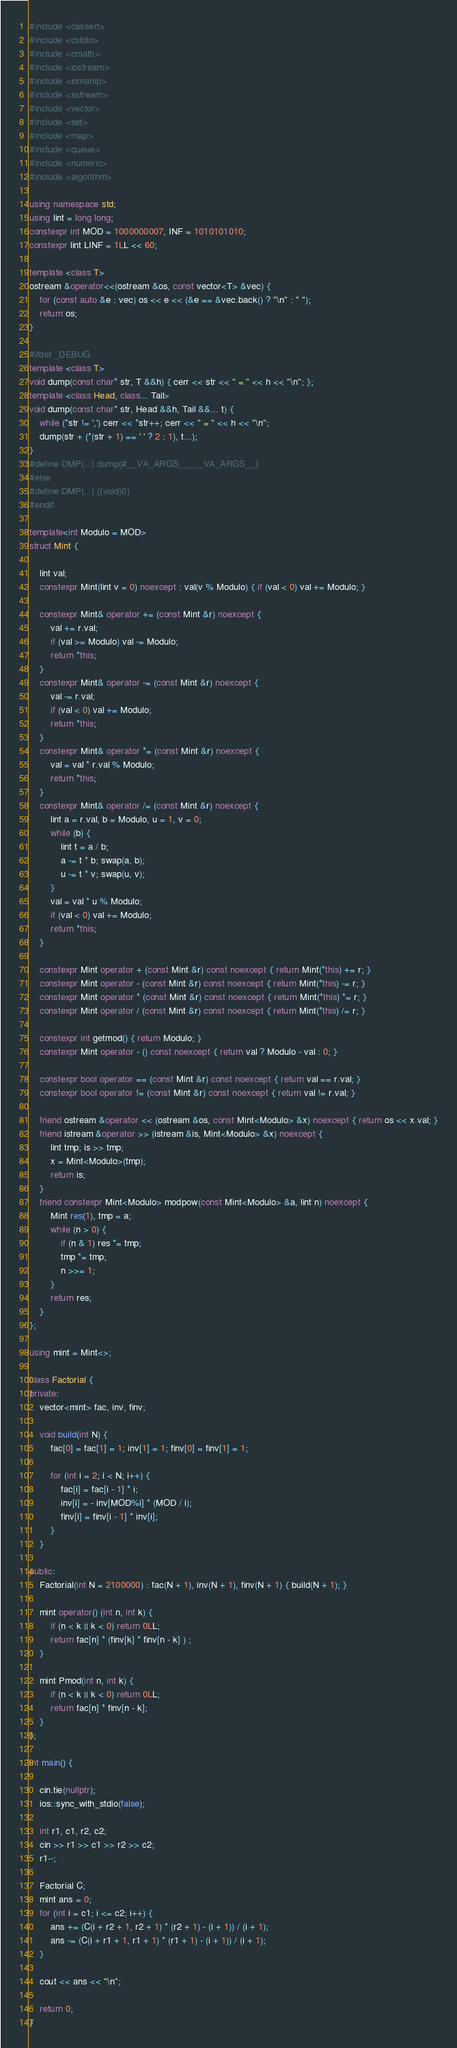Convert code to text. <code><loc_0><loc_0><loc_500><loc_500><_C++_>#include <cassert>
#include <cstdio>
#include <cmath>
#include <iostream>
#include <iomanip>
#include <sstream>
#include <vector>
#include <set>
#include <map>
#include <queue>
#include <numeric>
#include <algorithm>

using namespace std;
using lint = long long;
constexpr int MOD = 1000000007, INF = 1010101010;
constexpr lint LINF = 1LL << 60;

template <class T>
ostream &operator<<(ostream &os, const vector<T> &vec) {
	for (const auto &e : vec) os << e << (&e == &vec.back() ? "\n" : " ");
	return os;
}

#ifdef _DEBUG
template <class T>
void dump(const char* str, T &&h) { cerr << str << " = " << h << "\n"; };
template <class Head, class... Tail>
void dump(const char* str, Head &&h, Tail &&... t) {
	while (*str != ',') cerr << *str++; cerr << " = " << h << "\n";
	dump(str + (*(str + 1) == ' ' ? 2 : 1), t...);
}
#define DMP(...) dump(#__VA_ARGS__, __VA_ARGS__)
#else 
#define DMP(...) ((void)0)
#endif

template<int Modulo = MOD>
struct Mint {

	lint val;
	constexpr Mint(lint v = 0) noexcept : val(v % Modulo) { if (val < 0) val += Modulo; }

	constexpr Mint& operator += (const Mint &r) noexcept {
		val += r.val;
		if (val >= Modulo) val -= Modulo;
		return *this;
	}
	constexpr Mint& operator -= (const Mint &r) noexcept {
		val -= r.val;
		if (val < 0) val += Modulo;
		return *this;
	}
	constexpr Mint& operator *= (const Mint &r) noexcept {
		val = val * r.val % Modulo;
		return *this;
	}
	constexpr Mint& operator /= (const Mint &r) noexcept {
		lint a = r.val, b = Modulo, u = 1, v = 0;
		while (b) {
			lint t = a / b;
			a -= t * b; swap(a, b);
			u -= t * v; swap(u, v);
		}
		val = val * u % Modulo;
		if (val < 0) val += Modulo;
		return *this;
	}

	constexpr Mint operator + (const Mint &r) const noexcept { return Mint(*this) += r; }
	constexpr Mint operator - (const Mint &r) const noexcept { return Mint(*this) -= r; }
	constexpr Mint operator * (const Mint &r) const noexcept { return Mint(*this) *= r; }
	constexpr Mint operator / (const Mint &r) const noexcept { return Mint(*this) /= r; }

	constexpr int getmod() { return Modulo; }
	constexpr Mint operator - () const noexcept { return val ? Modulo - val : 0; }

	constexpr bool operator == (const Mint &r) const noexcept { return val == r.val; }
	constexpr bool operator != (const Mint &r) const noexcept { return val != r.val; }

	friend ostream &operator << (ostream &os, const Mint<Modulo> &x) noexcept { return os << x.val; }
	friend istream &operator >> (istream &is, Mint<Modulo> &x) noexcept {
		lint tmp; is >> tmp;
		x = Mint<Modulo>(tmp);
		return is;
	}
	friend constexpr Mint<Modulo> modpow(const Mint<Modulo> &a, lint n) noexcept {
		Mint res(1), tmp = a;
		while (n > 0) {
			if (n & 1) res *= tmp;
			tmp *= tmp;
			n >>= 1;
		}
		return res;
	}
};

using mint = Mint<>;

class Factorial {
private:
	vector<mint> fac, inv, finv;

	void build(int N) {
		fac[0] = fac[1] = 1; inv[1] = 1; finv[0] = finv[1] = 1;

		for (int i = 2; i < N; i++) {
			fac[i] = fac[i - 1] * i;
			inv[i] = - inv[MOD%i] * (MOD / i);
			finv[i] = finv[i - 1] * inv[i];
		}
	}

public:
	Factorial(int N = 2100000) : fac(N + 1), inv(N + 1), finv(N + 1) { build(N + 1); }

	mint operator() (int n, int k) {
		if (n < k || k < 0) return 0LL;
		return fac[n] * (finv[k] * finv[n - k] ) ;
	}

	mint Pmod(int n, int k) {
		if (n < k || k < 0) return 0LL;
		return fac[n] * finv[n - k];
	}
};

int main() {

	cin.tie(nullptr);
	ios::sync_with_stdio(false);

	int r1, c1, r2, c2;
	cin >> r1 >> c1 >> r2 >> c2;
	r1--;

	Factorial C;
	mint ans = 0;
	for (int i = c1; i <= c2; i++) {
		ans += (C(i + r2 + 1, r2 + 1) * (r2 + 1) - (i + 1)) / (i + 1);
		ans -= (C(i + r1 + 1, r1 + 1) * (r1 + 1) - (i + 1)) / (i + 1);
	}

	cout << ans << "\n";

	return 0;
}</code> 